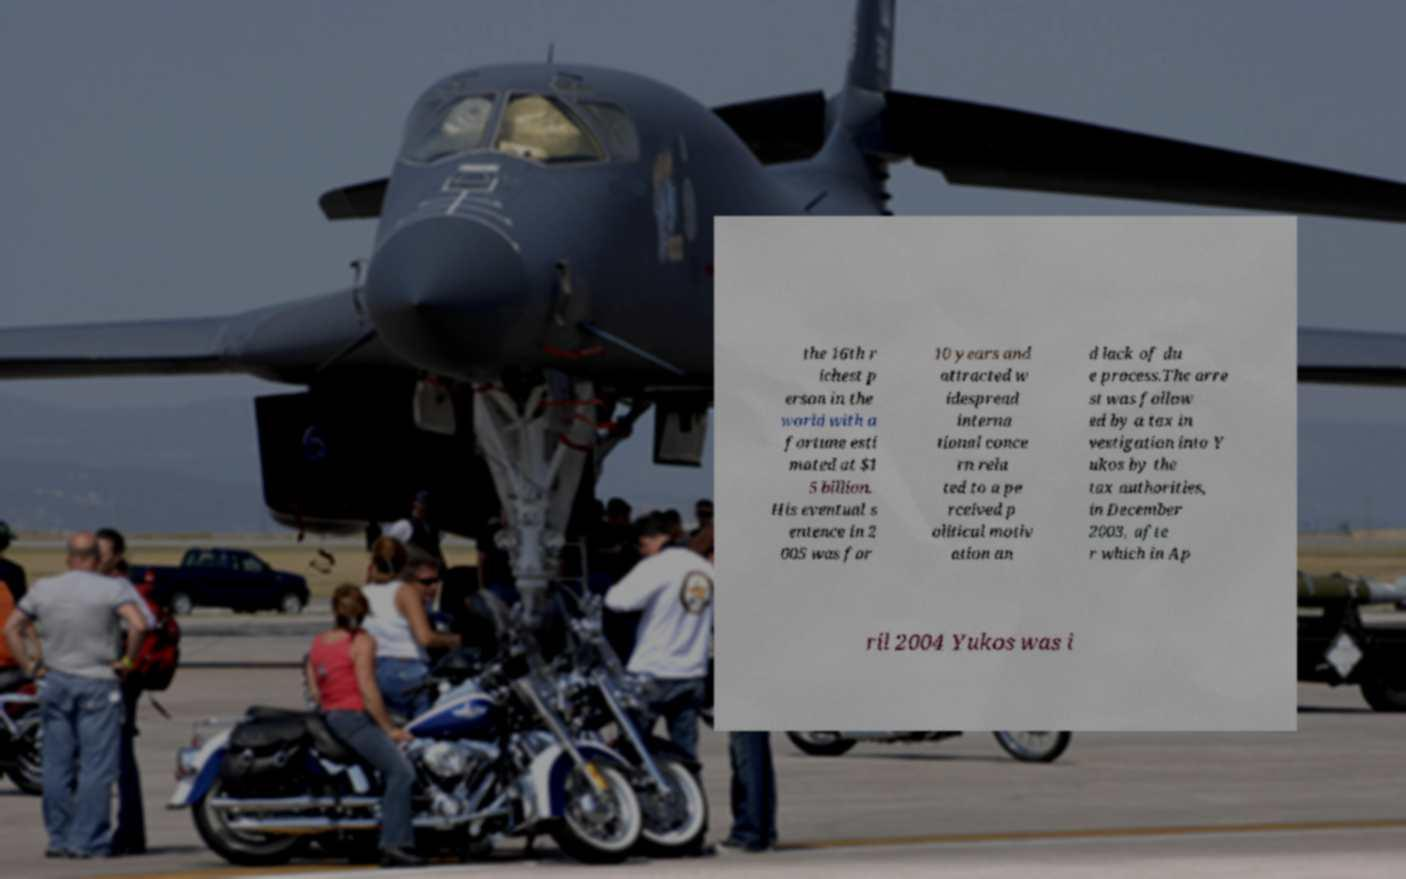Please identify and transcribe the text found in this image. the 16th r ichest p erson in the world with a fortune esti mated at $1 5 billion. His eventual s entence in 2 005 was for 10 years and attracted w idespread interna tional conce rn rela ted to a pe rceived p olitical motiv ation an d lack of du e process.The arre st was follow ed by a tax in vestigation into Y ukos by the tax authorities, in December 2003, afte r which in Ap ril 2004 Yukos was i 